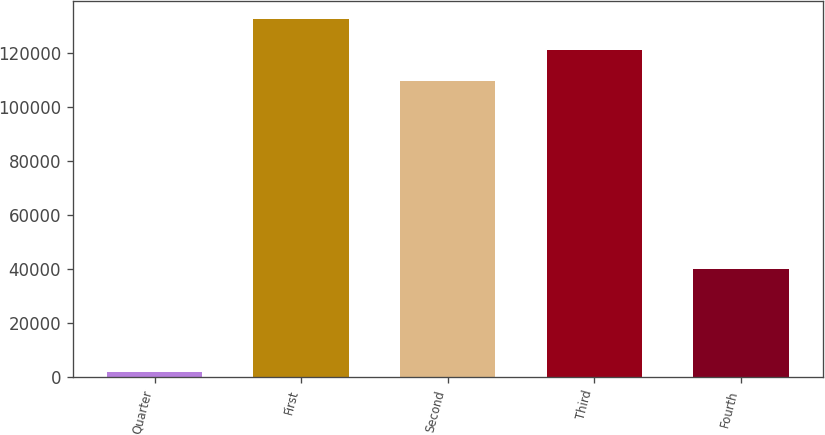Convert chart to OTSL. <chart><loc_0><loc_0><loc_500><loc_500><bar_chart><fcel>Quarter<fcel>First<fcel>Second<fcel>Third<fcel>Fourth<nl><fcel>2017<fcel>132544<fcel>109795<fcel>121170<fcel>40155<nl></chart> 